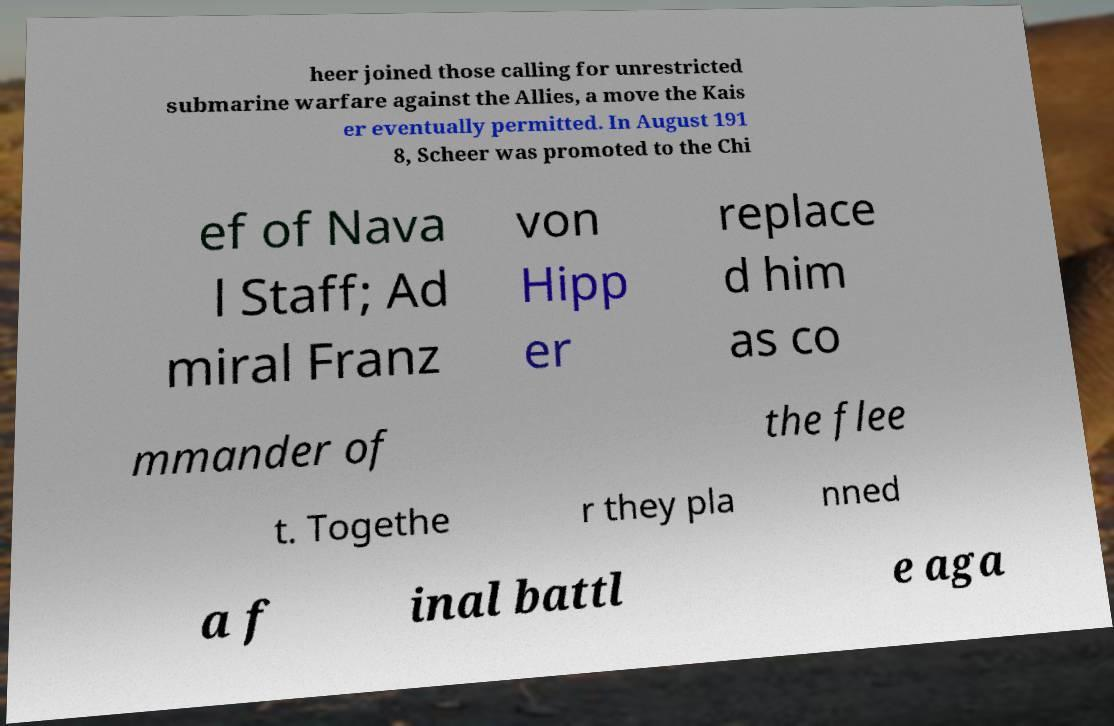I need the written content from this picture converted into text. Can you do that? heer joined those calling for unrestricted submarine warfare against the Allies, a move the Kais er eventually permitted. In August 191 8, Scheer was promoted to the Chi ef of Nava l Staff; Ad miral Franz von Hipp er replace d him as co mmander of the flee t. Togethe r they pla nned a f inal battl e aga 